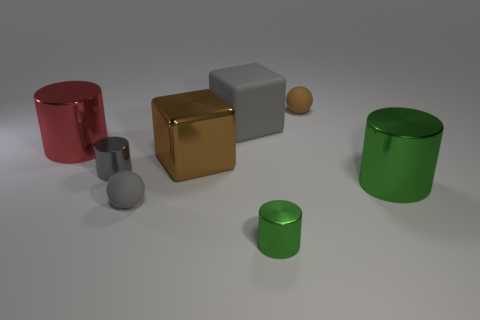Subtract all tiny green shiny cylinders. How many cylinders are left? 3 Subtract all gray cylinders. How many cylinders are left? 3 Subtract all balls. How many objects are left? 6 Subtract 2 blocks. How many blocks are left? 0 Subtract all purple balls. How many gray cubes are left? 1 Add 3 large brown spheres. How many large brown spheres exist? 3 Add 1 tiny purple metal cubes. How many objects exist? 9 Subtract 0 yellow cylinders. How many objects are left? 8 Subtract all yellow cylinders. Subtract all cyan spheres. How many cylinders are left? 4 Subtract all tiny metal objects. Subtract all small gray rubber things. How many objects are left? 5 